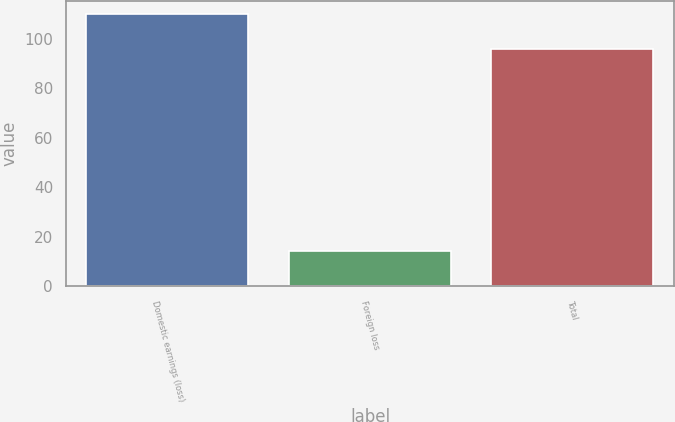<chart> <loc_0><loc_0><loc_500><loc_500><bar_chart><fcel>Domestic earnings (loss)<fcel>Foreign loss<fcel>Total<nl><fcel>110<fcel>14<fcel>96<nl></chart> 